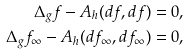Convert formula to latex. <formula><loc_0><loc_0><loc_500><loc_500>\Delta _ { g } f - A _ { h } ( d f , d f ) & = 0 , \\ \Delta _ { g } f _ { \infty } - A _ { h } ( d f _ { \infty } , d f _ { \infty } ) & = 0 ,</formula> 